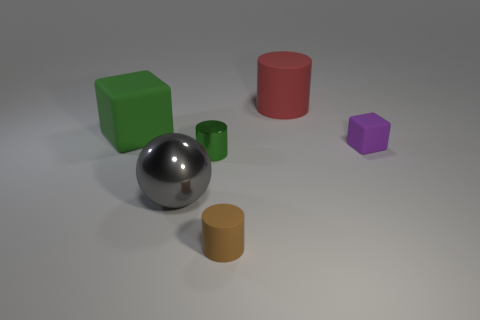Can you tell me which object on the picture looks the smoothest and why? The silver sphere in the center looks the smoothest due to its highly reflective surface, which suggests a very even and polished finish. 